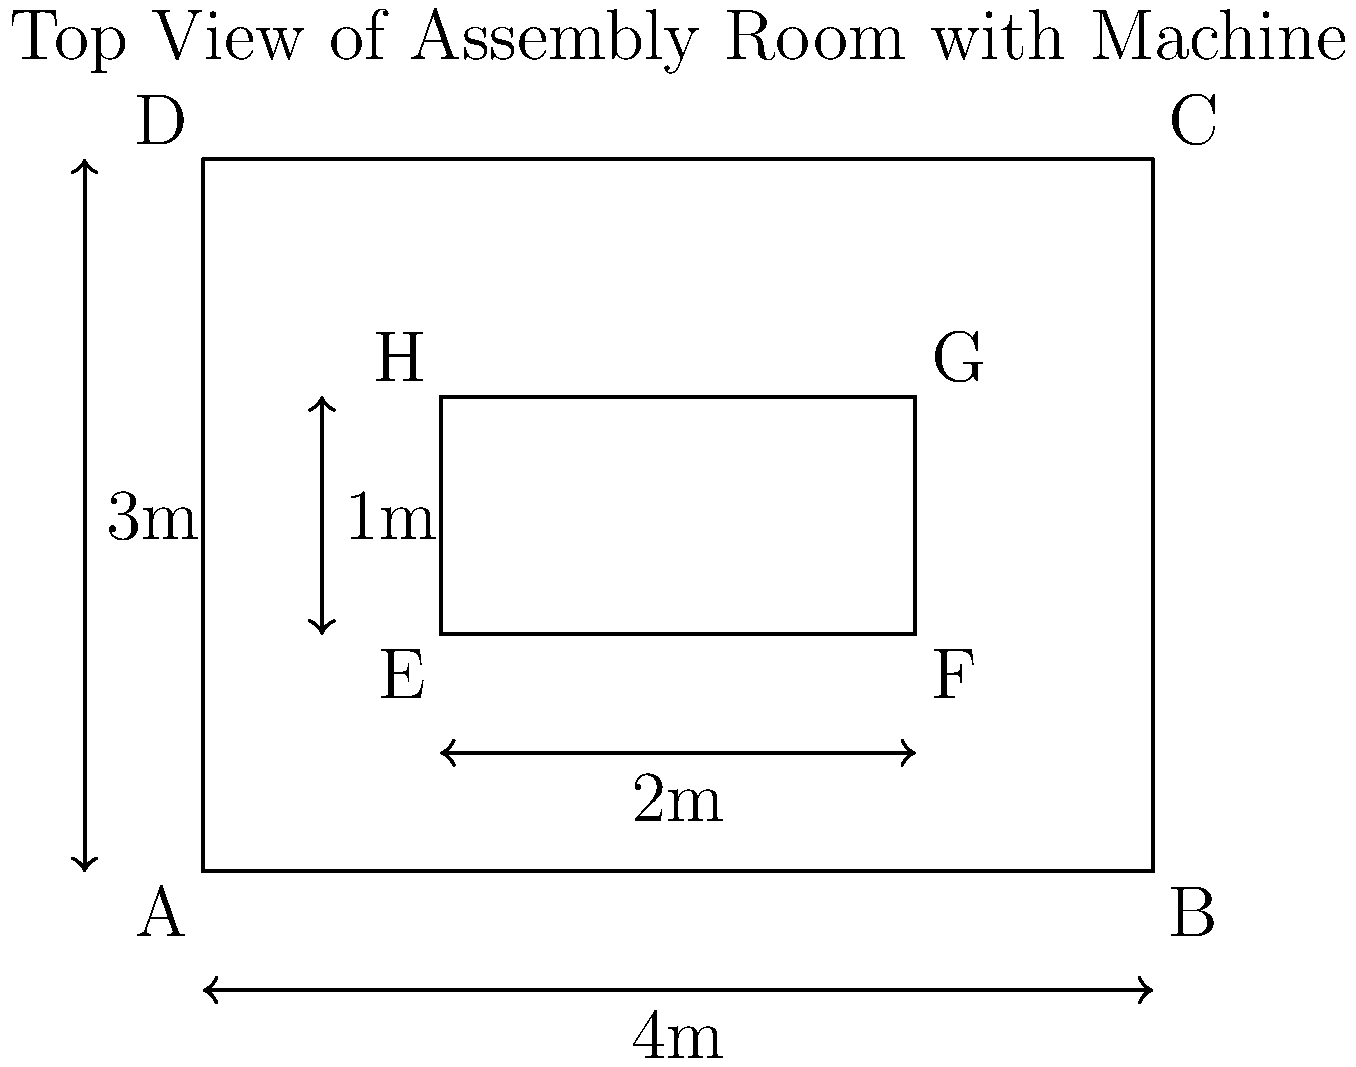Given the 2D blueprint of an assembly room with a machine, calculate the minimum clearance between the machine and any wall of the room. Assume the room dimensions are 4m x 3m, and the machine dimensions are 2m x 1m. To find the minimum clearance between the machine and any wall of the room, we need to follow these steps:

1. Identify the room dimensions:
   Length (AB or DC) = 4m
   Width (AD or BC) = 3m

2. Identify the machine dimensions:
   Length (EF or HG) = 2m
   Width (EH or FG) = 1m

3. Calculate the clearances:
   a) Left clearance = AE = 1m
   b) Right clearance = BF = 4m - 3m = 1m
   c) Top clearance = DH = 1m
   d) Bottom clearance = AG = 3m - 2m = 1m

4. Compare all clearances to find the minimum:
   All clearances are equal at 1m.

Therefore, the minimum clearance between the machine and any wall of the room is 1m.
Answer: 1m 